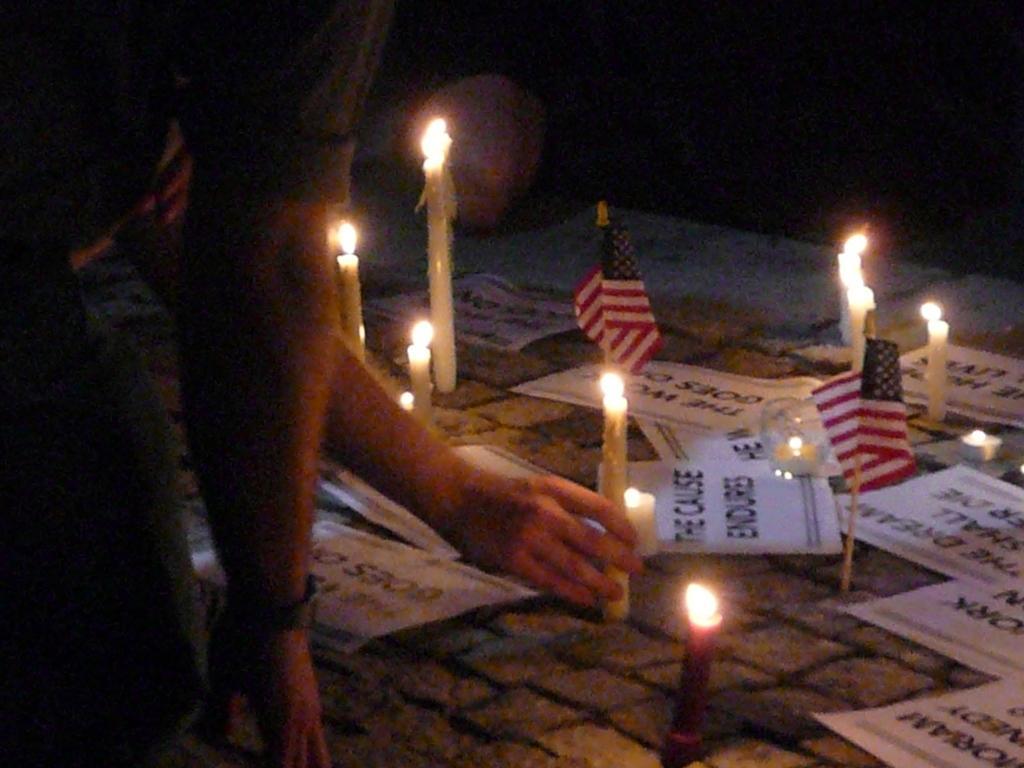Describe this image in one or two sentences. In this image, we can see people hands. There are candles, flags and papers in the middle of the image. 